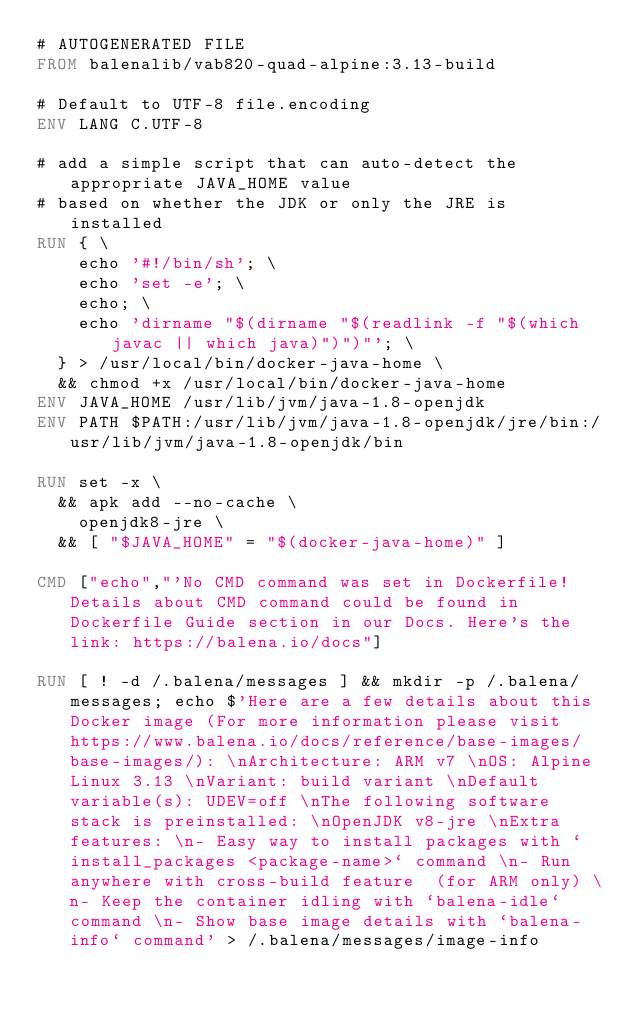<code> <loc_0><loc_0><loc_500><loc_500><_Dockerfile_># AUTOGENERATED FILE
FROM balenalib/vab820-quad-alpine:3.13-build

# Default to UTF-8 file.encoding
ENV LANG C.UTF-8

# add a simple script that can auto-detect the appropriate JAVA_HOME value
# based on whether the JDK or only the JRE is installed
RUN { \
		echo '#!/bin/sh'; \
		echo 'set -e'; \
		echo; \
		echo 'dirname "$(dirname "$(readlink -f "$(which javac || which java)")")"'; \
	} > /usr/local/bin/docker-java-home \
	&& chmod +x /usr/local/bin/docker-java-home
ENV JAVA_HOME /usr/lib/jvm/java-1.8-openjdk
ENV PATH $PATH:/usr/lib/jvm/java-1.8-openjdk/jre/bin:/usr/lib/jvm/java-1.8-openjdk/bin

RUN set -x \
	&& apk add --no-cache \
		openjdk8-jre \
	&& [ "$JAVA_HOME" = "$(docker-java-home)" ]

CMD ["echo","'No CMD command was set in Dockerfile! Details about CMD command could be found in Dockerfile Guide section in our Docs. Here's the link: https://balena.io/docs"]

RUN [ ! -d /.balena/messages ] && mkdir -p /.balena/messages; echo $'Here are a few details about this Docker image (For more information please visit https://www.balena.io/docs/reference/base-images/base-images/): \nArchitecture: ARM v7 \nOS: Alpine Linux 3.13 \nVariant: build variant \nDefault variable(s): UDEV=off \nThe following software stack is preinstalled: \nOpenJDK v8-jre \nExtra features: \n- Easy way to install packages with `install_packages <package-name>` command \n- Run anywhere with cross-build feature  (for ARM only) \n- Keep the container idling with `balena-idle` command \n- Show base image details with `balena-info` command' > /.balena/messages/image-info</code> 